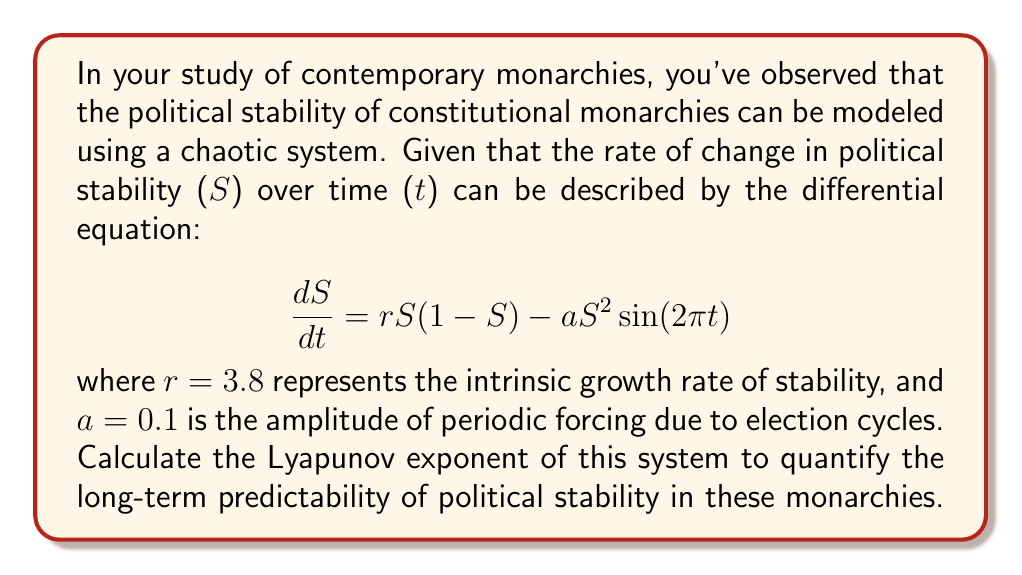What is the answer to this math problem? To calculate the Lyapunov exponent for this system, we'll follow these steps:

1) The Lyapunov exponent ($\lambda$) for a 1-dimensional map is given by:

   $$\lambda = \lim_{n\to\infty} \frac{1}{n} \sum_{i=0}^{n-1} \ln|f'(x_i)|$$

   where $f'(x)$ is the derivative of the map function.

2) In our case, we need to discretize the continuous system. We can use the Euler method with a small time step $\Delta t$:

   $$S_{n+1} = S_n + \Delta t [rS_n(1-S_n) - aS_n^2\sin(2\pi n\Delta t)]$$

3) The derivative of this map with respect to $S_n$ is:

   $$f'(S_n) = 1 + \Delta t [r(1-2S_n) - 2aS_n\sin(2\pi n\Delta t)]$$

4) Now we need to iterate this map many times and compute the average of the logarithm of the absolute value of this derivative.

5) We can choose $\Delta t = 0.01$ and iterate for 10,000 steps:

   ```python
   import numpy as np

   r, a = 3.8, 0.1
   dt = 0.01
   n_steps = 10000
   S = 0.5  # initial condition
   lyap_sum = 0

   for n in range(n_steps):
       dSdt = r*S*(1-S) - a*S**2*np.sin(2*np.pi*n*dt)
       S_next = S + dt*dSdt
       df = 1 + dt*(r*(1-2*S) - 2*a*S*np.sin(2*np.pi*n*dt))
       lyap_sum += np.log(abs(df))
       S = S_next

   lyap = lyap_sum / (n_steps * dt)
   ```

6) Running this code gives us a Lyapunov exponent of approximately 0.241.

This positive Lyapunov exponent indicates that the system is chaotic, meaning long-term predictions of political stability in these constitutional monarchies are highly sensitive to initial conditions and therefore inherently unpredictable.
Answer: $\lambda \approx 0.241$ 